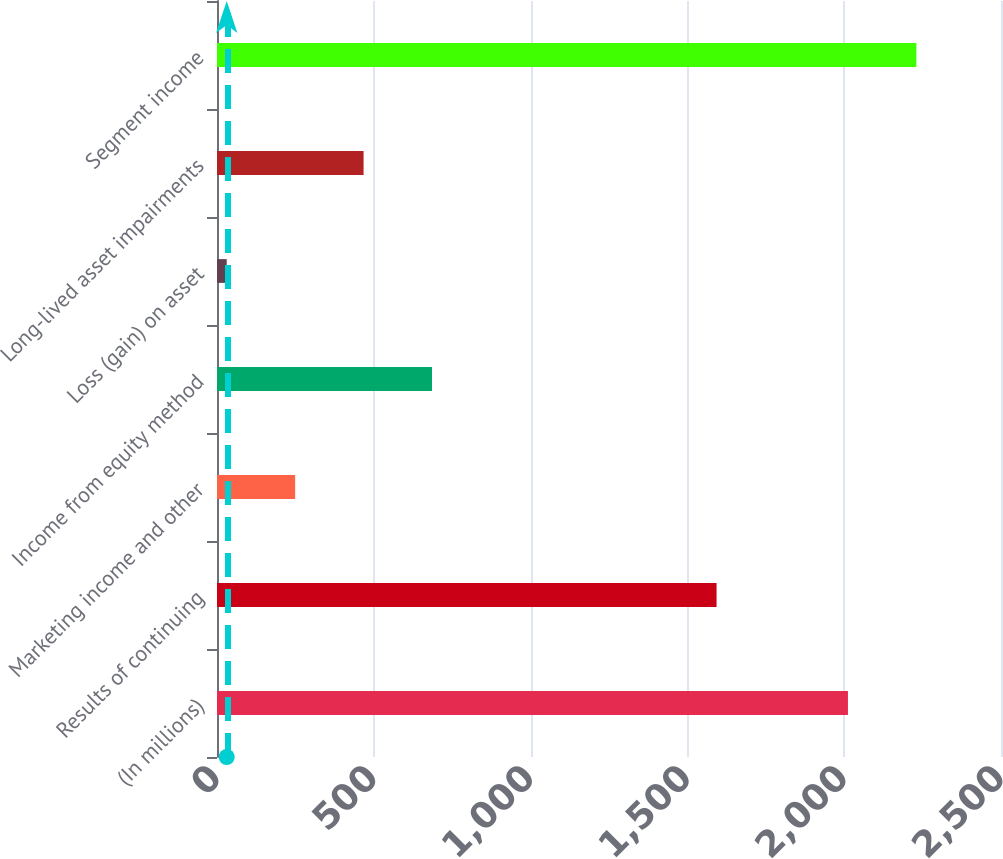Convert chart to OTSL. <chart><loc_0><loc_0><loc_500><loc_500><bar_chart><fcel>(In millions)<fcel>Results of continuing<fcel>Marketing income and other<fcel>Income from equity method<fcel>Loss (gain) on asset<fcel>Long-lived asset impairments<fcel>Segment income<nl><fcel>2012<fcel>1593<fcel>249.2<fcel>685.6<fcel>31<fcel>467.4<fcel>2230.2<nl></chart> 